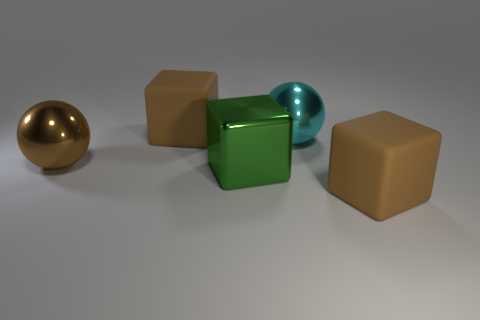Subtract all green blocks. How many blocks are left? 2 Add 4 tiny blue metal objects. How many objects exist? 9 Subtract 1 spheres. How many spheres are left? 1 Subtract all brown cubes. Subtract all yellow cylinders. How many cubes are left? 1 Subtract all yellow balls. How many green cubes are left? 1 Subtract all large metallic things. Subtract all brown matte cylinders. How many objects are left? 2 Add 2 big green things. How many big green things are left? 3 Add 4 brown shiny objects. How many brown shiny objects exist? 5 Subtract all green blocks. How many blocks are left? 2 Subtract 0 red balls. How many objects are left? 5 